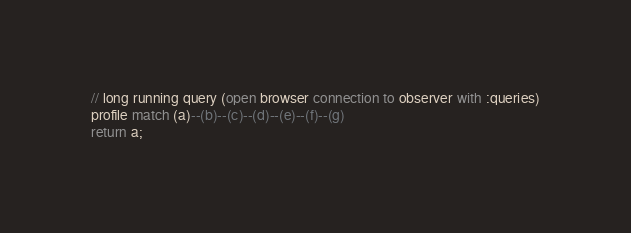<code> <loc_0><loc_0><loc_500><loc_500><_SQL_>
// long running query (open browser connection to observer with :queries)
profile match (a)--(b)--(c)--(d)--(e)--(f)--(g)
return a;</code> 